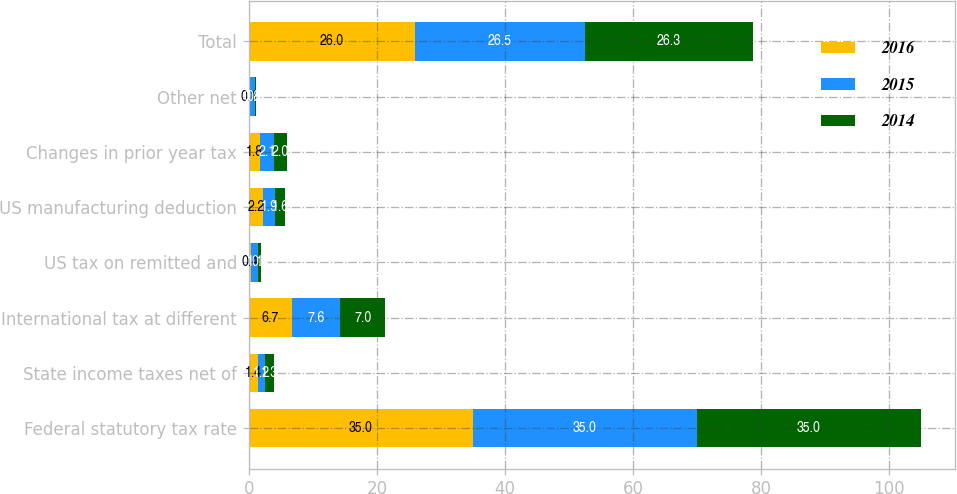Convert chart to OTSL. <chart><loc_0><loc_0><loc_500><loc_500><stacked_bar_chart><ecel><fcel>Federal statutory tax rate<fcel>State income taxes net of<fcel>International tax at different<fcel>US tax on remitted and<fcel>US manufacturing deduction<fcel>Changes in prior year tax<fcel>Other net<fcel>Total<nl><fcel>2016<fcel>35<fcel>1.4<fcel>6.7<fcel>0.4<fcel>2.2<fcel>1.8<fcel>0.1<fcel>26<nl><fcel>2015<fcel>35<fcel>1.2<fcel>7.6<fcel>1.1<fcel>1.9<fcel>2.1<fcel>0.8<fcel>26.5<nl><fcel>2014<fcel>35<fcel>1.3<fcel>7<fcel>0.4<fcel>1.6<fcel>2<fcel>0.2<fcel>26.3<nl></chart> 